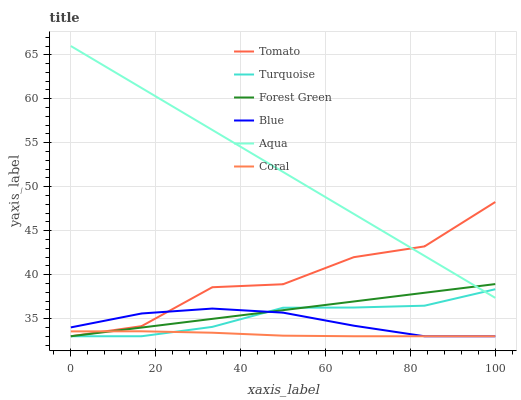Does Coral have the minimum area under the curve?
Answer yes or no. Yes. Does Aqua have the maximum area under the curve?
Answer yes or no. Yes. Does Blue have the minimum area under the curve?
Answer yes or no. No. Does Blue have the maximum area under the curve?
Answer yes or no. No. Is Aqua the smoothest?
Answer yes or no. Yes. Is Tomato the roughest?
Answer yes or no. Yes. Is Blue the smoothest?
Answer yes or no. No. Is Blue the roughest?
Answer yes or no. No. Does Tomato have the lowest value?
Answer yes or no. Yes. Does Aqua have the lowest value?
Answer yes or no. No. Does Aqua have the highest value?
Answer yes or no. Yes. Does Blue have the highest value?
Answer yes or no. No. Is Coral less than Aqua?
Answer yes or no. Yes. Is Aqua greater than Coral?
Answer yes or no. Yes. Does Tomato intersect Aqua?
Answer yes or no. Yes. Is Tomato less than Aqua?
Answer yes or no. No. Is Tomato greater than Aqua?
Answer yes or no. No. Does Coral intersect Aqua?
Answer yes or no. No. 